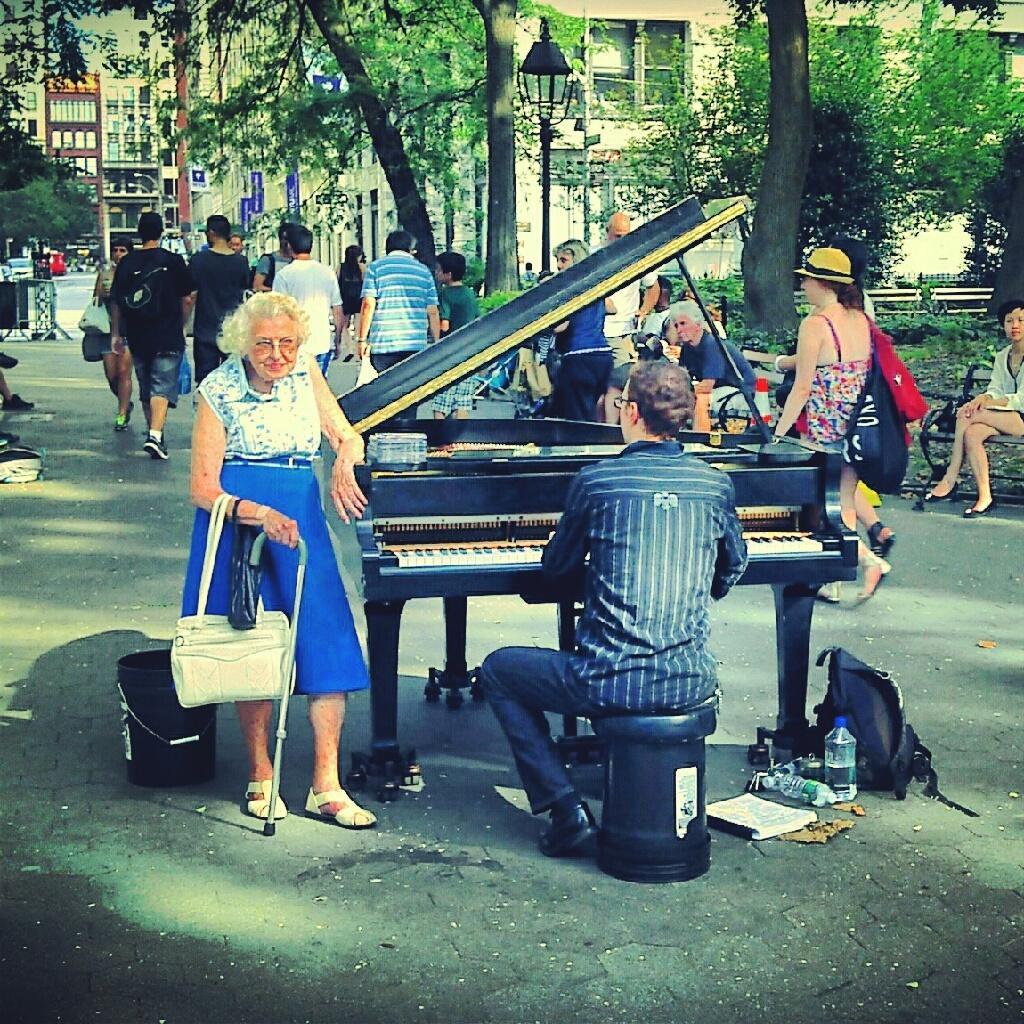Could you give a brief overview of what you see in this image? In this picture there is a woman standing beside the piano there is a guy sitting on the stool and playing piano here. There is a bag here on the road. In the background there are some people walking and sitting here. We can observe some trees and buildings too. 